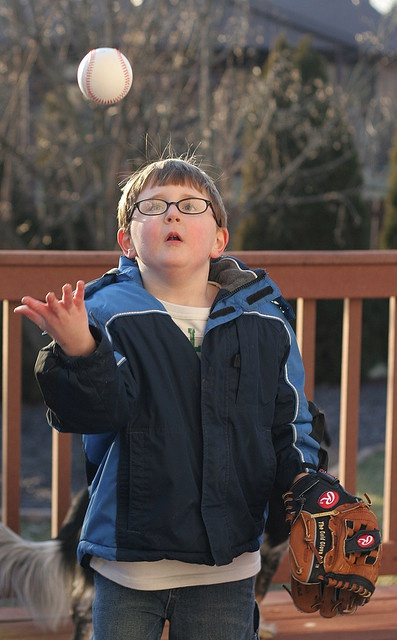Describe the objects in this image and their specific colors. I can see people in gray, black, brown, and tan tones, baseball glove in gray, black, maroon, and brown tones, dog in gray, black, and darkgray tones, and sports ball in gray, ivory, tan, and darkgray tones in this image. 